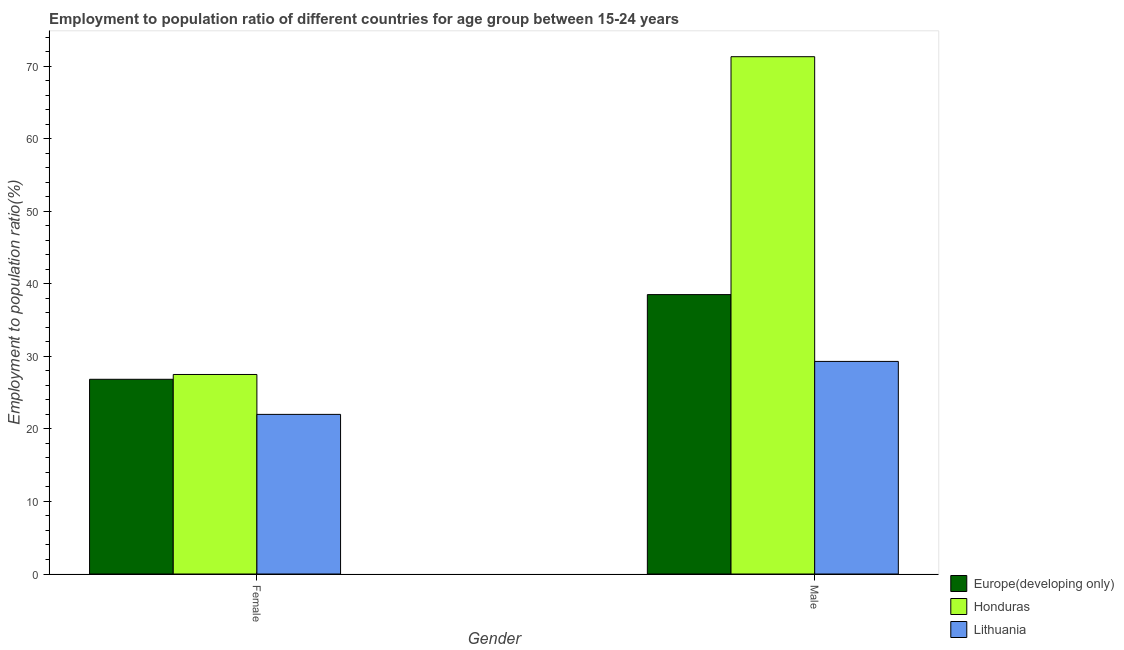How many different coloured bars are there?
Ensure brevity in your answer.  3. How many groups of bars are there?
Give a very brief answer. 2. Are the number of bars per tick equal to the number of legend labels?
Your response must be concise. Yes. What is the employment to population ratio(male) in Lithuania?
Your response must be concise. 29.3. Across all countries, what is the maximum employment to population ratio(female)?
Your answer should be compact. 27.5. In which country was the employment to population ratio(female) maximum?
Provide a short and direct response. Honduras. In which country was the employment to population ratio(female) minimum?
Make the answer very short. Lithuania. What is the total employment to population ratio(male) in the graph?
Your response must be concise. 139.11. What is the difference between the employment to population ratio(male) in Europe(developing only) and that in Lithuania?
Your answer should be compact. 9.21. What is the difference between the employment to population ratio(male) in Honduras and the employment to population ratio(female) in Europe(developing only)?
Offer a terse response. 44.46. What is the average employment to population ratio(male) per country?
Offer a terse response. 46.37. What is the difference between the employment to population ratio(female) and employment to population ratio(male) in Honduras?
Keep it short and to the point. -43.8. What is the ratio of the employment to population ratio(female) in Honduras to that in Lithuania?
Offer a terse response. 1.25. Is the employment to population ratio(male) in Honduras less than that in Europe(developing only)?
Ensure brevity in your answer.  No. In how many countries, is the employment to population ratio(male) greater than the average employment to population ratio(male) taken over all countries?
Ensure brevity in your answer.  1. What does the 1st bar from the left in Male represents?
Ensure brevity in your answer.  Europe(developing only). What does the 2nd bar from the right in Female represents?
Offer a very short reply. Honduras. Are all the bars in the graph horizontal?
Provide a succinct answer. No. Are the values on the major ticks of Y-axis written in scientific E-notation?
Your answer should be compact. No. Does the graph contain any zero values?
Offer a terse response. No. Where does the legend appear in the graph?
Offer a very short reply. Bottom right. How many legend labels are there?
Keep it short and to the point. 3. How are the legend labels stacked?
Provide a short and direct response. Vertical. What is the title of the graph?
Ensure brevity in your answer.  Employment to population ratio of different countries for age group between 15-24 years. What is the label or title of the X-axis?
Provide a short and direct response. Gender. What is the Employment to population ratio(%) of Europe(developing only) in Female?
Keep it short and to the point. 26.84. What is the Employment to population ratio(%) of Lithuania in Female?
Offer a very short reply. 22. What is the Employment to population ratio(%) in Europe(developing only) in Male?
Offer a terse response. 38.51. What is the Employment to population ratio(%) of Honduras in Male?
Make the answer very short. 71.3. What is the Employment to population ratio(%) in Lithuania in Male?
Your answer should be very brief. 29.3. Across all Gender, what is the maximum Employment to population ratio(%) of Europe(developing only)?
Offer a very short reply. 38.51. Across all Gender, what is the maximum Employment to population ratio(%) in Honduras?
Provide a short and direct response. 71.3. Across all Gender, what is the maximum Employment to population ratio(%) in Lithuania?
Provide a short and direct response. 29.3. Across all Gender, what is the minimum Employment to population ratio(%) in Europe(developing only)?
Your response must be concise. 26.84. Across all Gender, what is the minimum Employment to population ratio(%) of Honduras?
Your answer should be compact. 27.5. What is the total Employment to population ratio(%) of Europe(developing only) in the graph?
Offer a terse response. 65.35. What is the total Employment to population ratio(%) in Honduras in the graph?
Your response must be concise. 98.8. What is the total Employment to population ratio(%) of Lithuania in the graph?
Make the answer very short. 51.3. What is the difference between the Employment to population ratio(%) in Europe(developing only) in Female and that in Male?
Offer a very short reply. -11.67. What is the difference between the Employment to population ratio(%) in Honduras in Female and that in Male?
Your response must be concise. -43.8. What is the difference between the Employment to population ratio(%) in Europe(developing only) in Female and the Employment to population ratio(%) in Honduras in Male?
Provide a succinct answer. -44.46. What is the difference between the Employment to population ratio(%) in Europe(developing only) in Female and the Employment to population ratio(%) in Lithuania in Male?
Provide a succinct answer. -2.46. What is the difference between the Employment to population ratio(%) in Honduras in Female and the Employment to population ratio(%) in Lithuania in Male?
Your answer should be compact. -1.8. What is the average Employment to population ratio(%) of Europe(developing only) per Gender?
Give a very brief answer. 32.67. What is the average Employment to population ratio(%) in Honduras per Gender?
Provide a short and direct response. 49.4. What is the average Employment to population ratio(%) of Lithuania per Gender?
Keep it short and to the point. 25.65. What is the difference between the Employment to population ratio(%) in Europe(developing only) and Employment to population ratio(%) in Honduras in Female?
Provide a short and direct response. -0.66. What is the difference between the Employment to population ratio(%) of Europe(developing only) and Employment to population ratio(%) of Lithuania in Female?
Ensure brevity in your answer.  4.84. What is the difference between the Employment to population ratio(%) of Honduras and Employment to population ratio(%) of Lithuania in Female?
Give a very brief answer. 5.5. What is the difference between the Employment to population ratio(%) of Europe(developing only) and Employment to population ratio(%) of Honduras in Male?
Make the answer very short. -32.79. What is the difference between the Employment to population ratio(%) of Europe(developing only) and Employment to population ratio(%) of Lithuania in Male?
Offer a very short reply. 9.21. What is the difference between the Employment to population ratio(%) of Honduras and Employment to population ratio(%) of Lithuania in Male?
Provide a short and direct response. 42. What is the ratio of the Employment to population ratio(%) of Europe(developing only) in Female to that in Male?
Your answer should be compact. 0.7. What is the ratio of the Employment to population ratio(%) of Honduras in Female to that in Male?
Make the answer very short. 0.39. What is the ratio of the Employment to population ratio(%) in Lithuania in Female to that in Male?
Offer a terse response. 0.75. What is the difference between the highest and the second highest Employment to population ratio(%) of Europe(developing only)?
Give a very brief answer. 11.67. What is the difference between the highest and the second highest Employment to population ratio(%) in Honduras?
Your answer should be very brief. 43.8. What is the difference between the highest and the second highest Employment to population ratio(%) of Lithuania?
Keep it short and to the point. 7.3. What is the difference between the highest and the lowest Employment to population ratio(%) of Europe(developing only)?
Your response must be concise. 11.67. What is the difference between the highest and the lowest Employment to population ratio(%) of Honduras?
Your answer should be compact. 43.8. What is the difference between the highest and the lowest Employment to population ratio(%) in Lithuania?
Give a very brief answer. 7.3. 